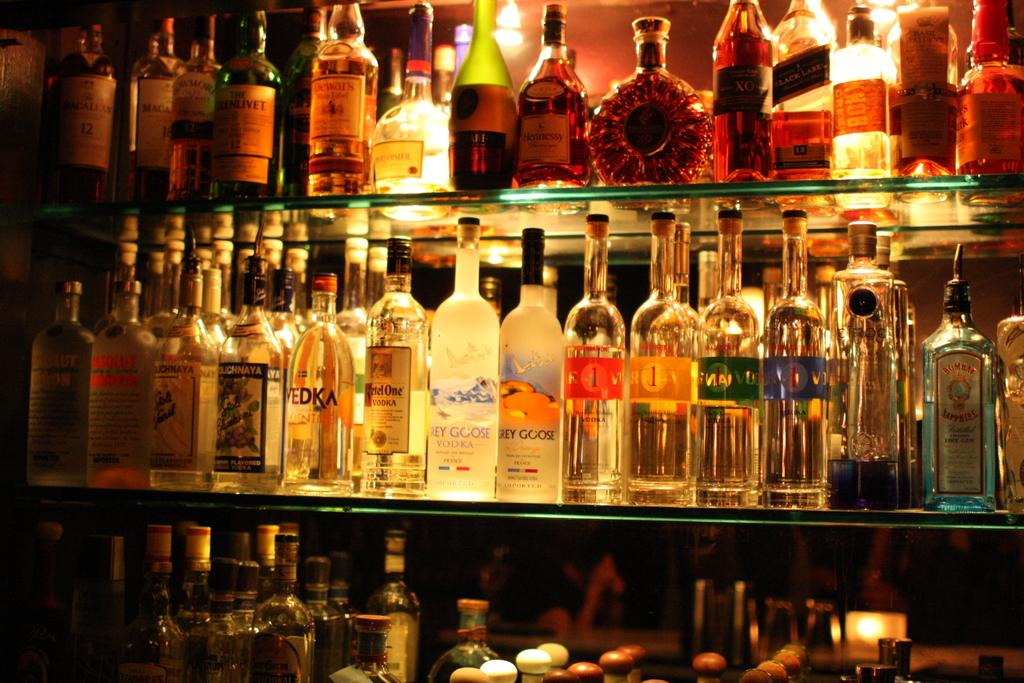<image>
Relay a brief, clear account of the picture shown. Several bottles of liquor, including Grey Goose and Svedka, line shelves. 